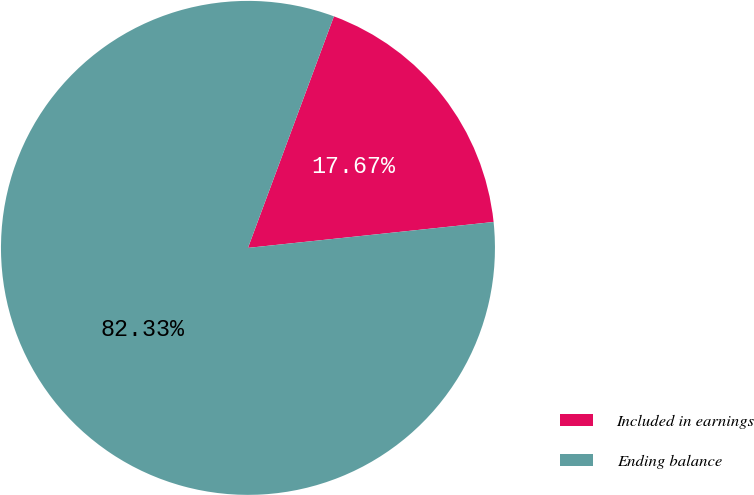Convert chart to OTSL. <chart><loc_0><loc_0><loc_500><loc_500><pie_chart><fcel>Included in earnings<fcel>Ending balance<nl><fcel>17.67%<fcel>82.33%<nl></chart> 